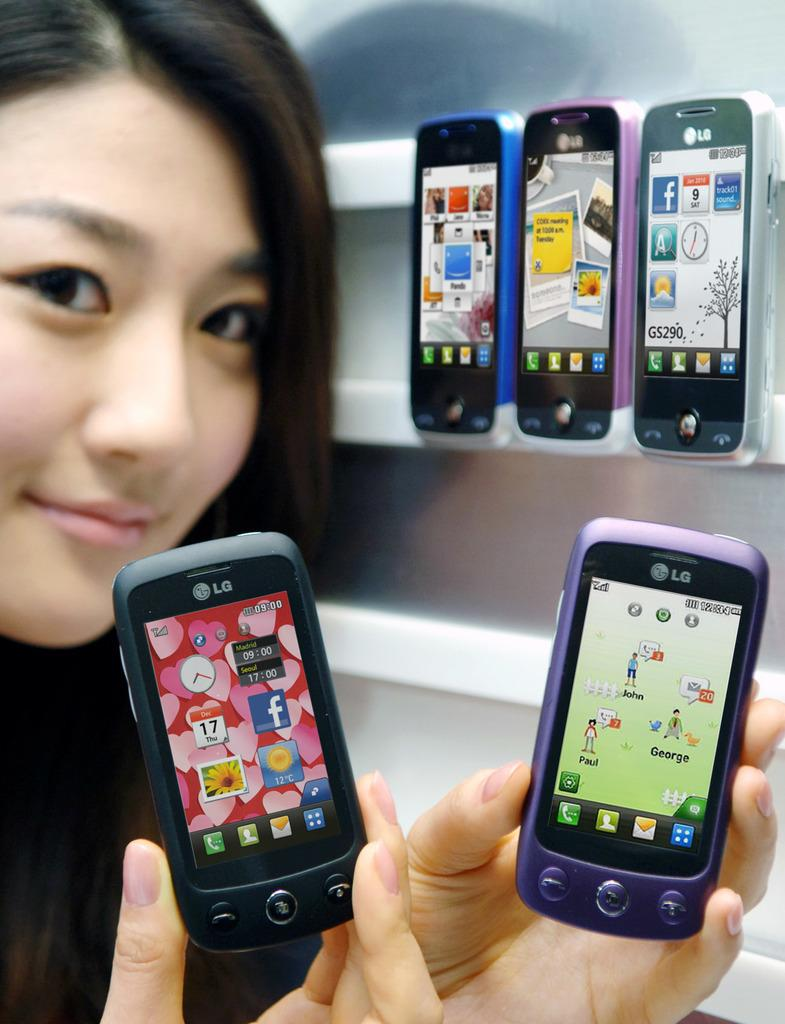<image>
Offer a succinct explanation of the picture presented. A woman holds up two different colored LG phones. 